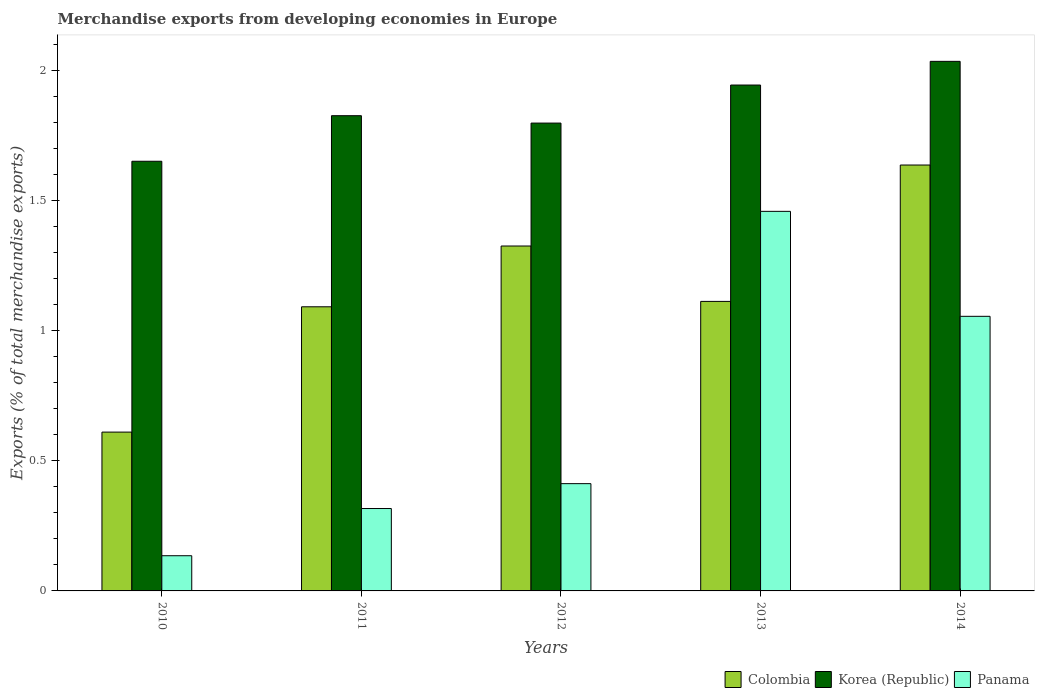How many different coloured bars are there?
Your answer should be compact. 3. How many bars are there on the 3rd tick from the left?
Give a very brief answer. 3. How many bars are there on the 2nd tick from the right?
Your response must be concise. 3. What is the label of the 4th group of bars from the left?
Give a very brief answer. 2013. What is the percentage of total merchandise exports in Colombia in 2010?
Give a very brief answer. 0.61. Across all years, what is the maximum percentage of total merchandise exports in Korea (Republic)?
Keep it short and to the point. 2.03. Across all years, what is the minimum percentage of total merchandise exports in Korea (Republic)?
Make the answer very short. 1.65. In which year was the percentage of total merchandise exports in Korea (Republic) maximum?
Make the answer very short. 2014. What is the total percentage of total merchandise exports in Panama in the graph?
Offer a terse response. 3.38. What is the difference between the percentage of total merchandise exports in Colombia in 2012 and that in 2013?
Your response must be concise. 0.21. What is the difference between the percentage of total merchandise exports in Korea (Republic) in 2011 and the percentage of total merchandise exports in Panama in 2012?
Keep it short and to the point. 1.41. What is the average percentage of total merchandise exports in Korea (Republic) per year?
Your response must be concise. 1.85. In the year 2010, what is the difference between the percentage of total merchandise exports in Colombia and percentage of total merchandise exports in Korea (Republic)?
Your answer should be compact. -1.04. What is the ratio of the percentage of total merchandise exports in Panama in 2012 to that in 2014?
Your answer should be compact. 0.39. Is the percentage of total merchandise exports in Panama in 2012 less than that in 2013?
Offer a terse response. Yes. What is the difference between the highest and the second highest percentage of total merchandise exports in Colombia?
Your response must be concise. 0.31. What is the difference between the highest and the lowest percentage of total merchandise exports in Colombia?
Keep it short and to the point. 1.03. What does the 2nd bar from the left in 2013 represents?
Provide a succinct answer. Korea (Republic). What does the 2nd bar from the right in 2011 represents?
Ensure brevity in your answer.  Korea (Republic). Is it the case that in every year, the sum of the percentage of total merchandise exports in Panama and percentage of total merchandise exports in Colombia is greater than the percentage of total merchandise exports in Korea (Republic)?
Your response must be concise. No. How many years are there in the graph?
Provide a succinct answer. 5. What is the difference between two consecutive major ticks on the Y-axis?
Keep it short and to the point. 0.5. Are the values on the major ticks of Y-axis written in scientific E-notation?
Provide a succinct answer. No. Does the graph contain any zero values?
Your response must be concise. No. How many legend labels are there?
Offer a very short reply. 3. How are the legend labels stacked?
Give a very brief answer. Horizontal. What is the title of the graph?
Offer a terse response. Merchandise exports from developing economies in Europe. What is the label or title of the X-axis?
Your answer should be compact. Years. What is the label or title of the Y-axis?
Your answer should be very brief. Exports (% of total merchandise exports). What is the Exports (% of total merchandise exports) of Colombia in 2010?
Your answer should be compact. 0.61. What is the Exports (% of total merchandise exports) of Korea (Republic) in 2010?
Ensure brevity in your answer.  1.65. What is the Exports (% of total merchandise exports) in Panama in 2010?
Offer a terse response. 0.14. What is the Exports (% of total merchandise exports) in Colombia in 2011?
Offer a terse response. 1.09. What is the Exports (% of total merchandise exports) in Korea (Republic) in 2011?
Provide a succinct answer. 1.83. What is the Exports (% of total merchandise exports) of Panama in 2011?
Keep it short and to the point. 0.32. What is the Exports (% of total merchandise exports) in Colombia in 2012?
Your answer should be very brief. 1.32. What is the Exports (% of total merchandise exports) in Korea (Republic) in 2012?
Provide a short and direct response. 1.8. What is the Exports (% of total merchandise exports) of Panama in 2012?
Give a very brief answer. 0.41. What is the Exports (% of total merchandise exports) in Colombia in 2013?
Provide a short and direct response. 1.11. What is the Exports (% of total merchandise exports) in Korea (Republic) in 2013?
Give a very brief answer. 1.94. What is the Exports (% of total merchandise exports) in Panama in 2013?
Provide a short and direct response. 1.46. What is the Exports (% of total merchandise exports) in Colombia in 2014?
Offer a terse response. 1.64. What is the Exports (% of total merchandise exports) in Korea (Republic) in 2014?
Your answer should be very brief. 2.03. What is the Exports (% of total merchandise exports) of Panama in 2014?
Keep it short and to the point. 1.05. Across all years, what is the maximum Exports (% of total merchandise exports) in Colombia?
Provide a short and direct response. 1.64. Across all years, what is the maximum Exports (% of total merchandise exports) of Korea (Republic)?
Your answer should be very brief. 2.03. Across all years, what is the maximum Exports (% of total merchandise exports) in Panama?
Your answer should be compact. 1.46. Across all years, what is the minimum Exports (% of total merchandise exports) of Colombia?
Make the answer very short. 0.61. Across all years, what is the minimum Exports (% of total merchandise exports) in Korea (Republic)?
Provide a short and direct response. 1.65. Across all years, what is the minimum Exports (% of total merchandise exports) of Panama?
Your answer should be compact. 0.14. What is the total Exports (% of total merchandise exports) in Colombia in the graph?
Your response must be concise. 5.77. What is the total Exports (% of total merchandise exports) in Korea (Republic) in the graph?
Offer a terse response. 9.25. What is the total Exports (% of total merchandise exports) in Panama in the graph?
Offer a very short reply. 3.38. What is the difference between the Exports (% of total merchandise exports) in Colombia in 2010 and that in 2011?
Provide a succinct answer. -0.48. What is the difference between the Exports (% of total merchandise exports) of Korea (Republic) in 2010 and that in 2011?
Give a very brief answer. -0.17. What is the difference between the Exports (% of total merchandise exports) of Panama in 2010 and that in 2011?
Make the answer very short. -0.18. What is the difference between the Exports (% of total merchandise exports) of Colombia in 2010 and that in 2012?
Give a very brief answer. -0.71. What is the difference between the Exports (% of total merchandise exports) in Korea (Republic) in 2010 and that in 2012?
Ensure brevity in your answer.  -0.15. What is the difference between the Exports (% of total merchandise exports) in Panama in 2010 and that in 2012?
Offer a very short reply. -0.28. What is the difference between the Exports (% of total merchandise exports) of Colombia in 2010 and that in 2013?
Your answer should be very brief. -0.5. What is the difference between the Exports (% of total merchandise exports) of Korea (Republic) in 2010 and that in 2013?
Offer a terse response. -0.29. What is the difference between the Exports (% of total merchandise exports) of Panama in 2010 and that in 2013?
Offer a very short reply. -1.32. What is the difference between the Exports (% of total merchandise exports) in Colombia in 2010 and that in 2014?
Ensure brevity in your answer.  -1.03. What is the difference between the Exports (% of total merchandise exports) of Korea (Republic) in 2010 and that in 2014?
Make the answer very short. -0.38. What is the difference between the Exports (% of total merchandise exports) in Panama in 2010 and that in 2014?
Make the answer very short. -0.92. What is the difference between the Exports (% of total merchandise exports) in Colombia in 2011 and that in 2012?
Keep it short and to the point. -0.23. What is the difference between the Exports (% of total merchandise exports) of Korea (Republic) in 2011 and that in 2012?
Your response must be concise. 0.03. What is the difference between the Exports (% of total merchandise exports) of Panama in 2011 and that in 2012?
Keep it short and to the point. -0.1. What is the difference between the Exports (% of total merchandise exports) in Colombia in 2011 and that in 2013?
Your response must be concise. -0.02. What is the difference between the Exports (% of total merchandise exports) of Korea (Republic) in 2011 and that in 2013?
Ensure brevity in your answer.  -0.12. What is the difference between the Exports (% of total merchandise exports) in Panama in 2011 and that in 2013?
Keep it short and to the point. -1.14. What is the difference between the Exports (% of total merchandise exports) of Colombia in 2011 and that in 2014?
Give a very brief answer. -0.54. What is the difference between the Exports (% of total merchandise exports) in Korea (Republic) in 2011 and that in 2014?
Offer a terse response. -0.21. What is the difference between the Exports (% of total merchandise exports) in Panama in 2011 and that in 2014?
Ensure brevity in your answer.  -0.74. What is the difference between the Exports (% of total merchandise exports) of Colombia in 2012 and that in 2013?
Ensure brevity in your answer.  0.21. What is the difference between the Exports (% of total merchandise exports) of Korea (Republic) in 2012 and that in 2013?
Your answer should be very brief. -0.15. What is the difference between the Exports (% of total merchandise exports) in Panama in 2012 and that in 2013?
Provide a succinct answer. -1.05. What is the difference between the Exports (% of total merchandise exports) in Colombia in 2012 and that in 2014?
Provide a succinct answer. -0.31. What is the difference between the Exports (% of total merchandise exports) in Korea (Republic) in 2012 and that in 2014?
Your answer should be very brief. -0.24. What is the difference between the Exports (% of total merchandise exports) in Panama in 2012 and that in 2014?
Your response must be concise. -0.64. What is the difference between the Exports (% of total merchandise exports) in Colombia in 2013 and that in 2014?
Provide a short and direct response. -0.52. What is the difference between the Exports (% of total merchandise exports) in Korea (Republic) in 2013 and that in 2014?
Offer a very short reply. -0.09. What is the difference between the Exports (% of total merchandise exports) of Panama in 2013 and that in 2014?
Keep it short and to the point. 0.4. What is the difference between the Exports (% of total merchandise exports) of Colombia in 2010 and the Exports (% of total merchandise exports) of Korea (Republic) in 2011?
Offer a very short reply. -1.22. What is the difference between the Exports (% of total merchandise exports) of Colombia in 2010 and the Exports (% of total merchandise exports) of Panama in 2011?
Ensure brevity in your answer.  0.29. What is the difference between the Exports (% of total merchandise exports) in Korea (Republic) in 2010 and the Exports (% of total merchandise exports) in Panama in 2011?
Offer a very short reply. 1.33. What is the difference between the Exports (% of total merchandise exports) in Colombia in 2010 and the Exports (% of total merchandise exports) in Korea (Republic) in 2012?
Your response must be concise. -1.19. What is the difference between the Exports (% of total merchandise exports) of Colombia in 2010 and the Exports (% of total merchandise exports) of Panama in 2012?
Provide a short and direct response. 0.2. What is the difference between the Exports (% of total merchandise exports) in Korea (Republic) in 2010 and the Exports (% of total merchandise exports) in Panama in 2012?
Your response must be concise. 1.24. What is the difference between the Exports (% of total merchandise exports) in Colombia in 2010 and the Exports (% of total merchandise exports) in Korea (Republic) in 2013?
Give a very brief answer. -1.33. What is the difference between the Exports (% of total merchandise exports) of Colombia in 2010 and the Exports (% of total merchandise exports) of Panama in 2013?
Offer a terse response. -0.85. What is the difference between the Exports (% of total merchandise exports) in Korea (Republic) in 2010 and the Exports (% of total merchandise exports) in Panama in 2013?
Your response must be concise. 0.19. What is the difference between the Exports (% of total merchandise exports) in Colombia in 2010 and the Exports (% of total merchandise exports) in Korea (Republic) in 2014?
Provide a succinct answer. -1.42. What is the difference between the Exports (% of total merchandise exports) in Colombia in 2010 and the Exports (% of total merchandise exports) in Panama in 2014?
Offer a terse response. -0.44. What is the difference between the Exports (% of total merchandise exports) of Korea (Republic) in 2010 and the Exports (% of total merchandise exports) of Panama in 2014?
Ensure brevity in your answer.  0.6. What is the difference between the Exports (% of total merchandise exports) of Colombia in 2011 and the Exports (% of total merchandise exports) of Korea (Republic) in 2012?
Offer a very short reply. -0.71. What is the difference between the Exports (% of total merchandise exports) of Colombia in 2011 and the Exports (% of total merchandise exports) of Panama in 2012?
Offer a very short reply. 0.68. What is the difference between the Exports (% of total merchandise exports) of Korea (Republic) in 2011 and the Exports (% of total merchandise exports) of Panama in 2012?
Offer a terse response. 1.41. What is the difference between the Exports (% of total merchandise exports) of Colombia in 2011 and the Exports (% of total merchandise exports) of Korea (Republic) in 2013?
Keep it short and to the point. -0.85. What is the difference between the Exports (% of total merchandise exports) in Colombia in 2011 and the Exports (% of total merchandise exports) in Panama in 2013?
Your answer should be compact. -0.37. What is the difference between the Exports (% of total merchandise exports) in Korea (Republic) in 2011 and the Exports (% of total merchandise exports) in Panama in 2013?
Your response must be concise. 0.37. What is the difference between the Exports (% of total merchandise exports) in Colombia in 2011 and the Exports (% of total merchandise exports) in Korea (Republic) in 2014?
Give a very brief answer. -0.94. What is the difference between the Exports (% of total merchandise exports) of Colombia in 2011 and the Exports (% of total merchandise exports) of Panama in 2014?
Make the answer very short. 0.04. What is the difference between the Exports (% of total merchandise exports) in Korea (Republic) in 2011 and the Exports (% of total merchandise exports) in Panama in 2014?
Give a very brief answer. 0.77. What is the difference between the Exports (% of total merchandise exports) of Colombia in 2012 and the Exports (% of total merchandise exports) of Korea (Republic) in 2013?
Make the answer very short. -0.62. What is the difference between the Exports (% of total merchandise exports) of Colombia in 2012 and the Exports (% of total merchandise exports) of Panama in 2013?
Your answer should be very brief. -0.13. What is the difference between the Exports (% of total merchandise exports) in Korea (Republic) in 2012 and the Exports (% of total merchandise exports) in Panama in 2013?
Your answer should be very brief. 0.34. What is the difference between the Exports (% of total merchandise exports) in Colombia in 2012 and the Exports (% of total merchandise exports) in Korea (Republic) in 2014?
Give a very brief answer. -0.71. What is the difference between the Exports (% of total merchandise exports) in Colombia in 2012 and the Exports (% of total merchandise exports) in Panama in 2014?
Make the answer very short. 0.27. What is the difference between the Exports (% of total merchandise exports) in Korea (Republic) in 2012 and the Exports (% of total merchandise exports) in Panama in 2014?
Give a very brief answer. 0.74. What is the difference between the Exports (% of total merchandise exports) in Colombia in 2013 and the Exports (% of total merchandise exports) in Korea (Republic) in 2014?
Offer a terse response. -0.92. What is the difference between the Exports (% of total merchandise exports) in Colombia in 2013 and the Exports (% of total merchandise exports) in Panama in 2014?
Give a very brief answer. 0.06. What is the difference between the Exports (% of total merchandise exports) of Korea (Republic) in 2013 and the Exports (% of total merchandise exports) of Panama in 2014?
Ensure brevity in your answer.  0.89. What is the average Exports (% of total merchandise exports) in Colombia per year?
Give a very brief answer. 1.15. What is the average Exports (% of total merchandise exports) of Korea (Republic) per year?
Give a very brief answer. 1.85. What is the average Exports (% of total merchandise exports) in Panama per year?
Your answer should be very brief. 0.68. In the year 2010, what is the difference between the Exports (% of total merchandise exports) in Colombia and Exports (% of total merchandise exports) in Korea (Republic)?
Give a very brief answer. -1.04. In the year 2010, what is the difference between the Exports (% of total merchandise exports) of Colombia and Exports (% of total merchandise exports) of Panama?
Offer a terse response. 0.47. In the year 2010, what is the difference between the Exports (% of total merchandise exports) of Korea (Republic) and Exports (% of total merchandise exports) of Panama?
Ensure brevity in your answer.  1.51. In the year 2011, what is the difference between the Exports (% of total merchandise exports) of Colombia and Exports (% of total merchandise exports) of Korea (Republic)?
Provide a succinct answer. -0.73. In the year 2011, what is the difference between the Exports (% of total merchandise exports) in Colombia and Exports (% of total merchandise exports) in Panama?
Keep it short and to the point. 0.77. In the year 2011, what is the difference between the Exports (% of total merchandise exports) in Korea (Republic) and Exports (% of total merchandise exports) in Panama?
Make the answer very short. 1.51. In the year 2012, what is the difference between the Exports (% of total merchandise exports) of Colombia and Exports (% of total merchandise exports) of Korea (Republic)?
Provide a short and direct response. -0.47. In the year 2012, what is the difference between the Exports (% of total merchandise exports) of Colombia and Exports (% of total merchandise exports) of Panama?
Keep it short and to the point. 0.91. In the year 2012, what is the difference between the Exports (% of total merchandise exports) of Korea (Republic) and Exports (% of total merchandise exports) of Panama?
Your response must be concise. 1.38. In the year 2013, what is the difference between the Exports (% of total merchandise exports) of Colombia and Exports (% of total merchandise exports) of Korea (Republic)?
Offer a terse response. -0.83. In the year 2013, what is the difference between the Exports (% of total merchandise exports) of Colombia and Exports (% of total merchandise exports) of Panama?
Keep it short and to the point. -0.35. In the year 2013, what is the difference between the Exports (% of total merchandise exports) of Korea (Republic) and Exports (% of total merchandise exports) of Panama?
Provide a succinct answer. 0.49. In the year 2014, what is the difference between the Exports (% of total merchandise exports) of Colombia and Exports (% of total merchandise exports) of Korea (Republic)?
Offer a terse response. -0.4. In the year 2014, what is the difference between the Exports (% of total merchandise exports) in Colombia and Exports (% of total merchandise exports) in Panama?
Provide a succinct answer. 0.58. In the year 2014, what is the difference between the Exports (% of total merchandise exports) in Korea (Republic) and Exports (% of total merchandise exports) in Panama?
Your answer should be very brief. 0.98. What is the ratio of the Exports (% of total merchandise exports) in Colombia in 2010 to that in 2011?
Offer a very short reply. 0.56. What is the ratio of the Exports (% of total merchandise exports) in Korea (Republic) in 2010 to that in 2011?
Ensure brevity in your answer.  0.9. What is the ratio of the Exports (% of total merchandise exports) of Panama in 2010 to that in 2011?
Your response must be concise. 0.43. What is the ratio of the Exports (% of total merchandise exports) of Colombia in 2010 to that in 2012?
Provide a succinct answer. 0.46. What is the ratio of the Exports (% of total merchandise exports) in Korea (Republic) in 2010 to that in 2012?
Your response must be concise. 0.92. What is the ratio of the Exports (% of total merchandise exports) in Panama in 2010 to that in 2012?
Your answer should be very brief. 0.33. What is the ratio of the Exports (% of total merchandise exports) in Colombia in 2010 to that in 2013?
Ensure brevity in your answer.  0.55. What is the ratio of the Exports (% of total merchandise exports) of Korea (Republic) in 2010 to that in 2013?
Make the answer very short. 0.85. What is the ratio of the Exports (% of total merchandise exports) of Panama in 2010 to that in 2013?
Provide a succinct answer. 0.09. What is the ratio of the Exports (% of total merchandise exports) in Colombia in 2010 to that in 2014?
Your response must be concise. 0.37. What is the ratio of the Exports (% of total merchandise exports) of Korea (Republic) in 2010 to that in 2014?
Keep it short and to the point. 0.81. What is the ratio of the Exports (% of total merchandise exports) of Panama in 2010 to that in 2014?
Offer a terse response. 0.13. What is the ratio of the Exports (% of total merchandise exports) of Colombia in 2011 to that in 2012?
Your answer should be very brief. 0.82. What is the ratio of the Exports (% of total merchandise exports) in Korea (Republic) in 2011 to that in 2012?
Your answer should be compact. 1.02. What is the ratio of the Exports (% of total merchandise exports) of Panama in 2011 to that in 2012?
Offer a terse response. 0.77. What is the ratio of the Exports (% of total merchandise exports) in Colombia in 2011 to that in 2013?
Make the answer very short. 0.98. What is the ratio of the Exports (% of total merchandise exports) of Korea (Republic) in 2011 to that in 2013?
Your answer should be compact. 0.94. What is the ratio of the Exports (% of total merchandise exports) in Panama in 2011 to that in 2013?
Make the answer very short. 0.22. What is the ratio of the Exports (% of total merchandise exports) in Colombia in 2011 to that in 2014?
Give a very brief answer. 0.67. What is the ratio of the Exports (% of total merchandise exports) in Korea (Republic) in 2011 to that in 2014?
Make the answer very short. 0.9. What is the ratio of the Exports (% of total merchandise exports) of Panama in 2011 to that in 2014?
Make the answer very short. 0.3. What is the ratio of the Exports (% of total merchandise exports) in Colombia in 2012 to that in 2013?
Offer a terse response. 1.19. What is the ratio of the Exports (% of total merchandise exports) of Korea (Republic) in 2012 to that in 2013?
Your response must be concise. 0.92. What is the ratio of the Exports (% of total merchandise exports) in Panama in 2012 to that in 2013?
Your answer should be compact. 0.28. What is the ratio of the Exports (% of total merchandise exports) in Colombia in 2012 to that in 2014?
Give a very brief answer. 0.81. What is the ratio of the Exports (% of total merchandise exports) of Korea (Republic) in 2012 to that in 2014?
Make the answer very short. 0.88. What is the ratio of the Exports (% of total merchandise exports) in Panama in 2012 to that in 2014?
Make the answer very short. 0.39. What is the ratio of the Exports (% of total merchandise exports) of Colombia in 2013 to that in 2014?
Give a very brief answer. 0.68. What is the ratio of the Exports (% of total merchandise exports) of Korea (Republic) in 2013 to that in 2014?
Offer a very short reply. 0.96. What is the ratio of the Exports (% of total merchandise exports) of Panama in 2013 to that in 2014?
Give a very brief answer. 1.38. What is the difference between the highest and the second highest Exports (% of total merchandise exports) of Colombia?
Make the answer very short. 0.31. What is the difference between the highest and the second highest Exports (% of total merchandise exports) of Korea (Republic)?
Provide a succinct answer. 0.09. What is the difference between the highest and the second highest Exports (% of total merchandise exports) in Panama?
Provide a short and direct response. 0.4. What is the difference between the highest and the lowest Exports (% of total merchandise exports) in Colombia?
Provide a short and direct response. 1.03. What is the difference between the highest and the lowest Exports (% of total merchandise exports) of Korea (Republic)?
Your answer should be very brief. 0.38. What is the difference between the highest and the lowest Exports (% of total merchandise exports) in Panama?
Provide a short and direct response. 1.32. 